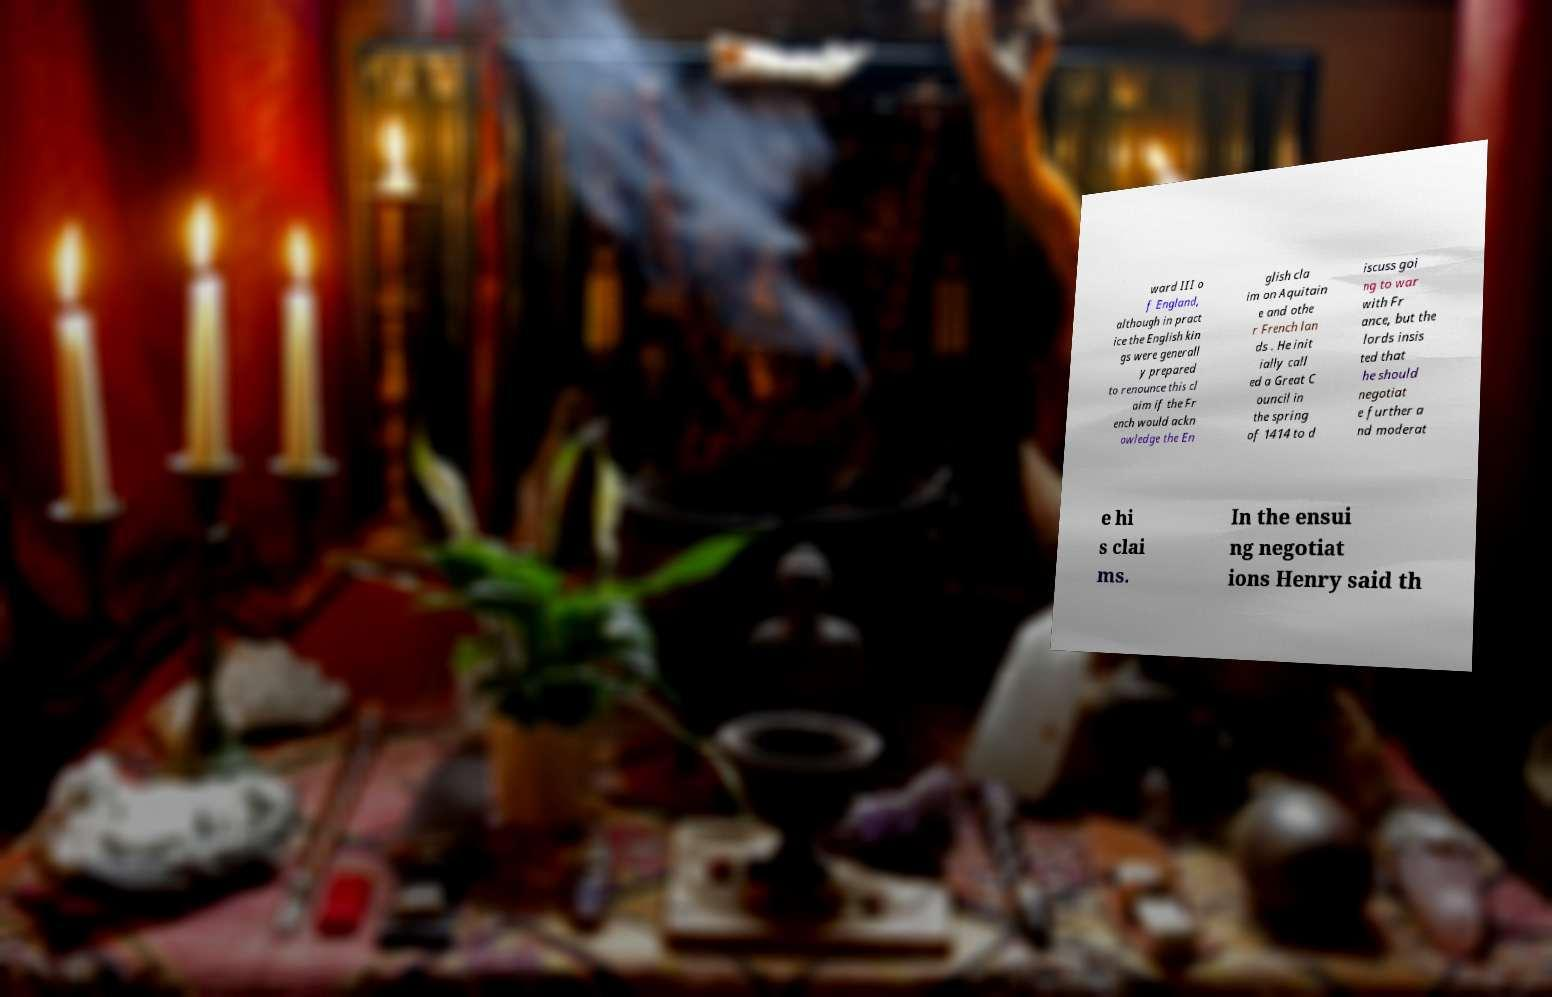What messages or text are displayed in this image? I need them in a readable, typed format. ward III o f England, although in pract ice the English kin gs were generall y prepared to renounce this cl aim if the Fr ench would ackn owledge the En glish cla im on Aquitain e and othe r French lan ds . He init ially call ed a Great C ouncil in the spring of 1414 to d iscuss goi ng to war with Fr ance, but the lords insis ted that he should negotiat e further a nd moderat e hi s clai ms. In the ensui ng negotiat ions Henry said th 